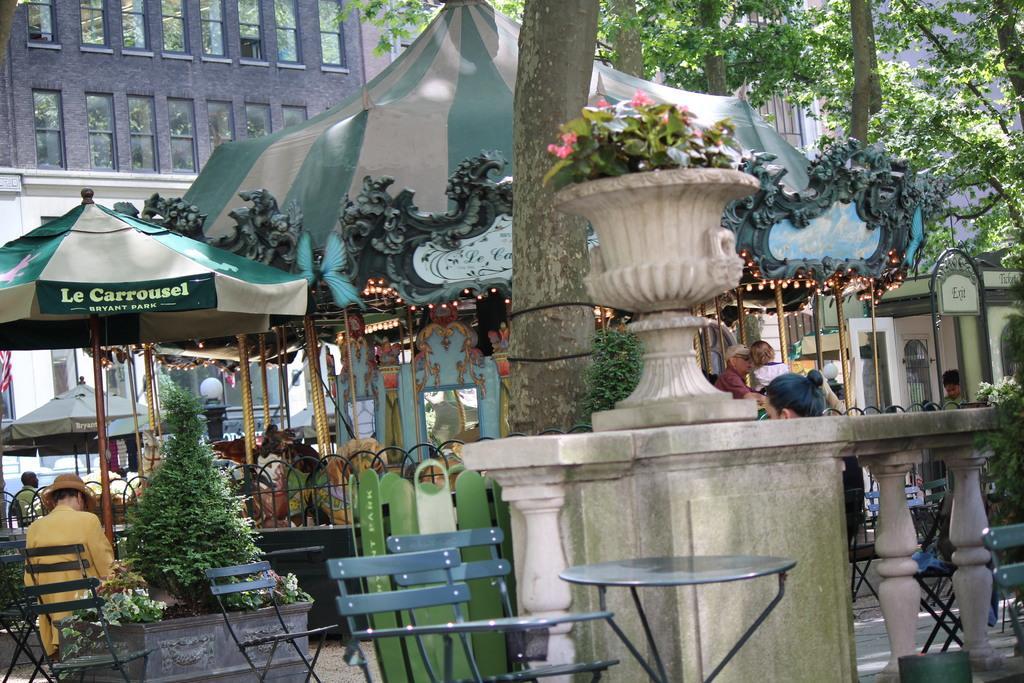How would you summarize this image in a sentence or two? In this picture there are people and we can see chairs, table, plants, flowers, pots, railing, fence, tents, trees, poles and lights. In the background of the image we can see buildings and windows. 